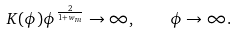<formula> <loc_0><loc_0><loc_500><loc_500>K ( \phi ) \phi ^ { \frac { 2 } { 1 + w _ { m } } } \rightarrow \infty , \quad \phi \rightarrow \infty .</formula> 